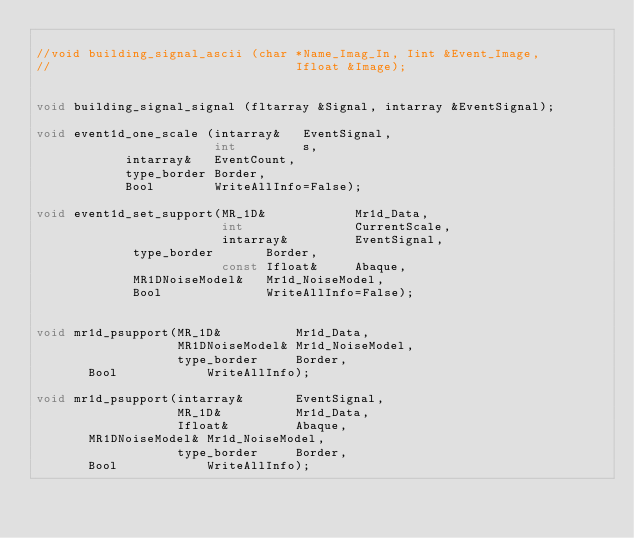<code> <loc_0><loc_0><loc_500><loc_500><_C_>
//void building_signal_ascii (char *Name_Imag_In, Iint &Event_Image, 
//                                 Ifloat &Image);


void building_signal_signal (fltarray &Signal, intarray &EventSignal);

void event1d_one_scale (intarray&   EventSignal, 
                        int         s, 
		        intarray&   EventCount, 
		        type_border Border,
		        Bool        WriteAllInfo=False);

void event1d_set_support(MR_1D&            Mr1d_Data, 
                         int               CurrentScale, 
                         intarray&         EventSignal, 
		         type_border       Border,
                         const Ifloat&     Abaque, 
		         MR1DNoiseModel&   Mr1d_NoiseModel,
		         Bool              WriteAllInfo=False);


void mr1d_psupport(MR_1D&          Mr1d_Data, 
                   MR1DNoiseModel& Mr1d_NoiseModel, 
                   type_border     Border,
		   Bool            WriteAllInfo);

void mr1d_psupport(intarray&       EventSignal, 
                   MR_1D&          Mr1d_Data, 
                   Ifloat&         Abaque, 
		   MR1DNoiseModel& Mr1d_NoiseModel, 
                   type_border     Border, 
		   Bool            WriteAllInfo);
</code> 